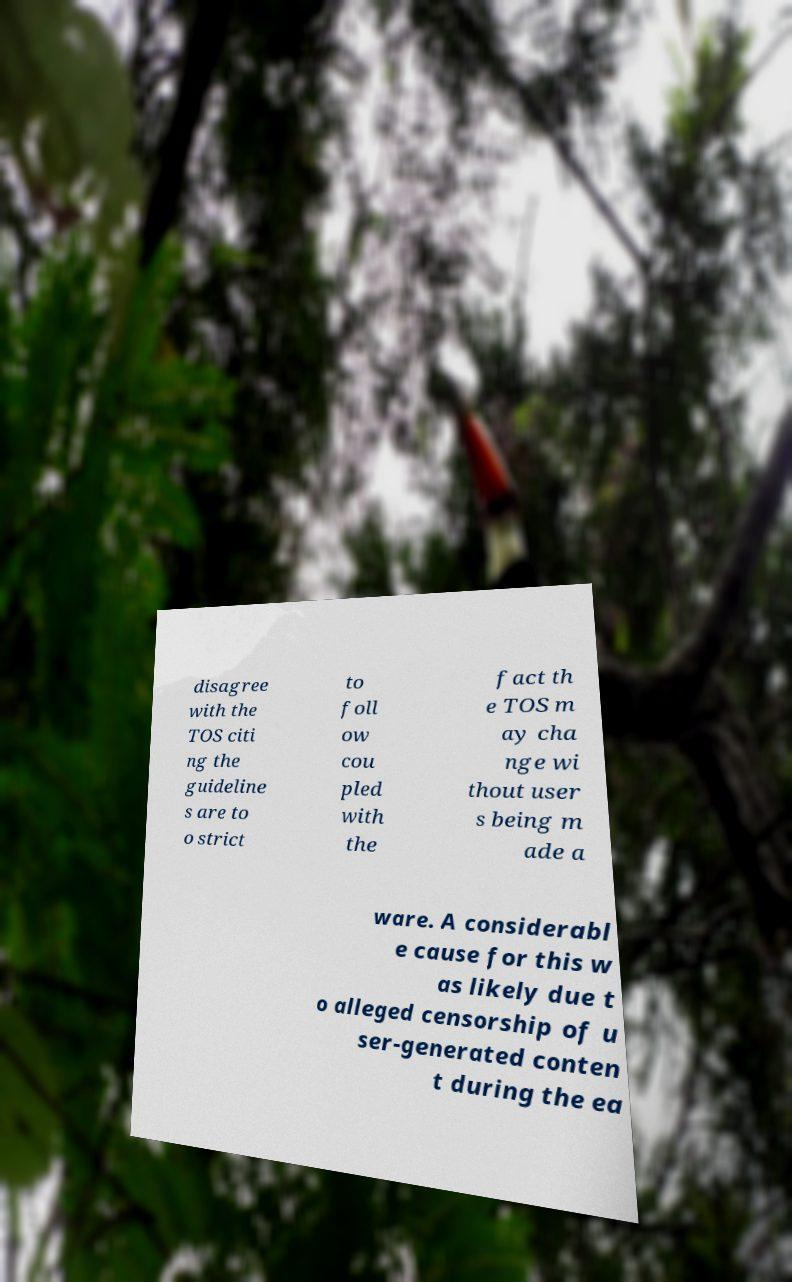Could you extract and type out the text from this image? disagree with the TOS citi ng the guideline s are to o strict to foll ow cou pled with the fact th e TOS m ay cha nge wi thout user s being m ade a ware. A considerabl e cause for this w as likely due t o alleged censorship of u ser-generated conten t during the ea 